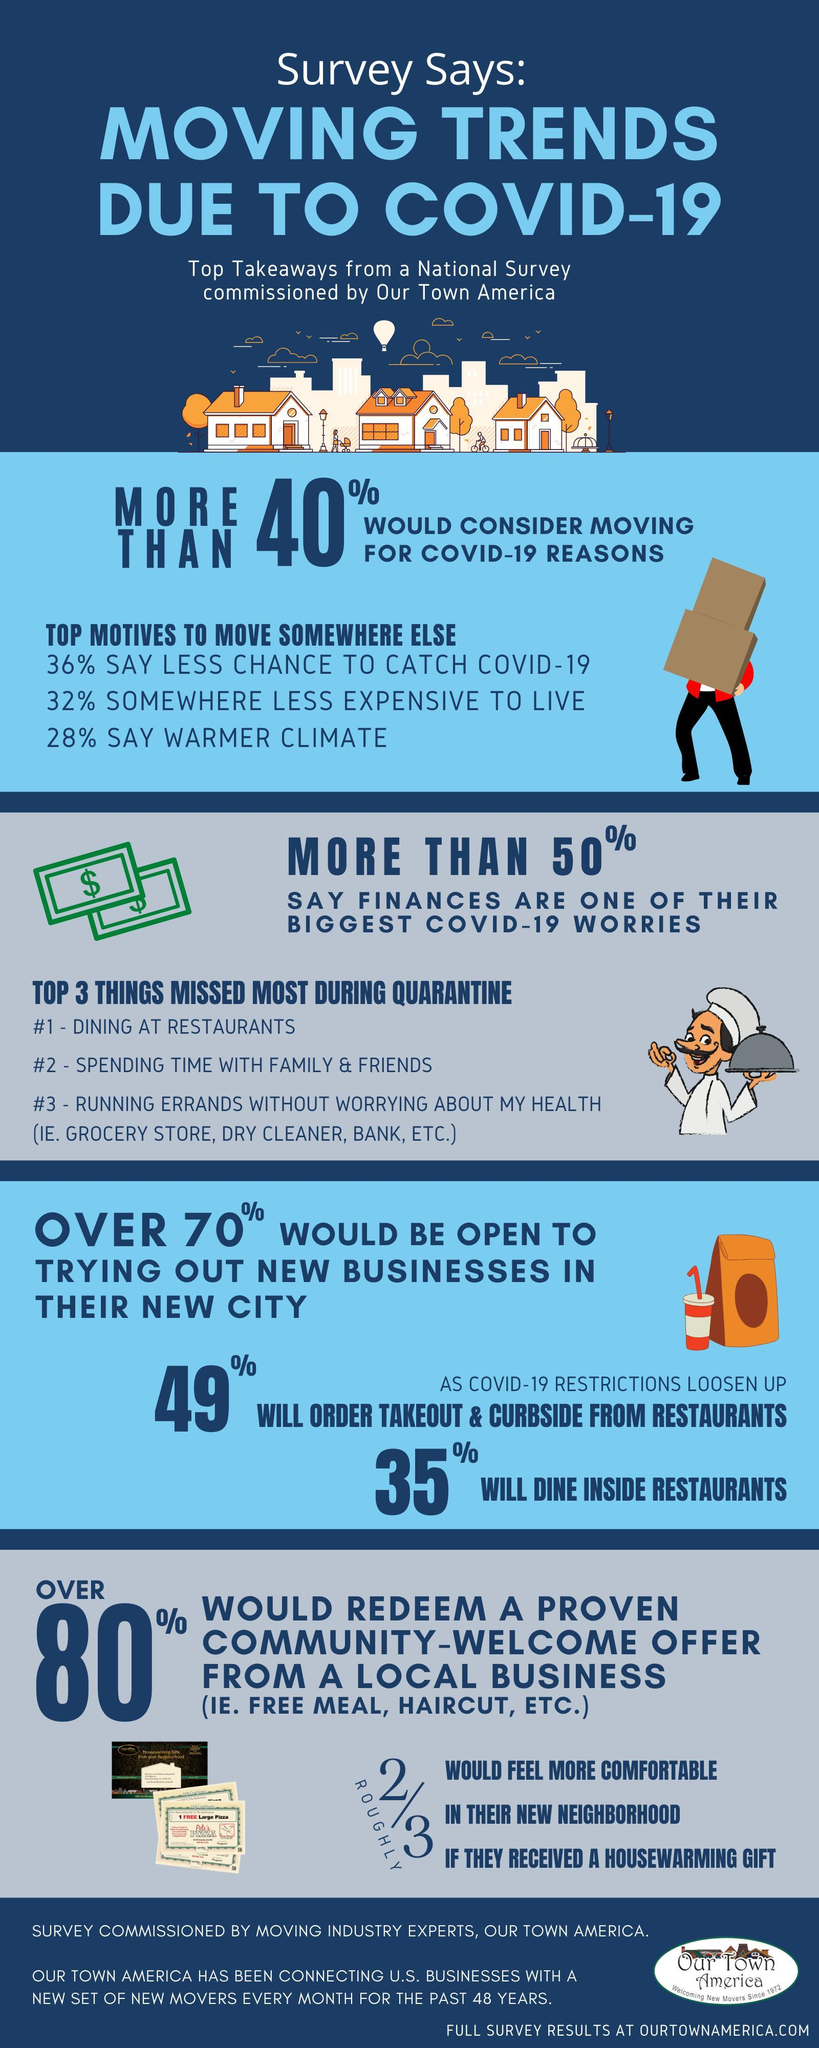what made more people move somewhere else, Covid-19 reasons or financial reasons?
Answer the question with a short phrase. to save from Covid-19 what is the total percentage of people moved because of climate reasons or financial reasons? 60 What is the second most missed thing during Covid-19? spending time with family and friends what is the total percentage of people moved because of covid-19 reasons or climate reasons? 64 What is the third most missed thing during Covid-19 according to the survey? running errands without worrying about my health what is the total percentage of people moved because of covid-19 reasons or financial reasons? 68 